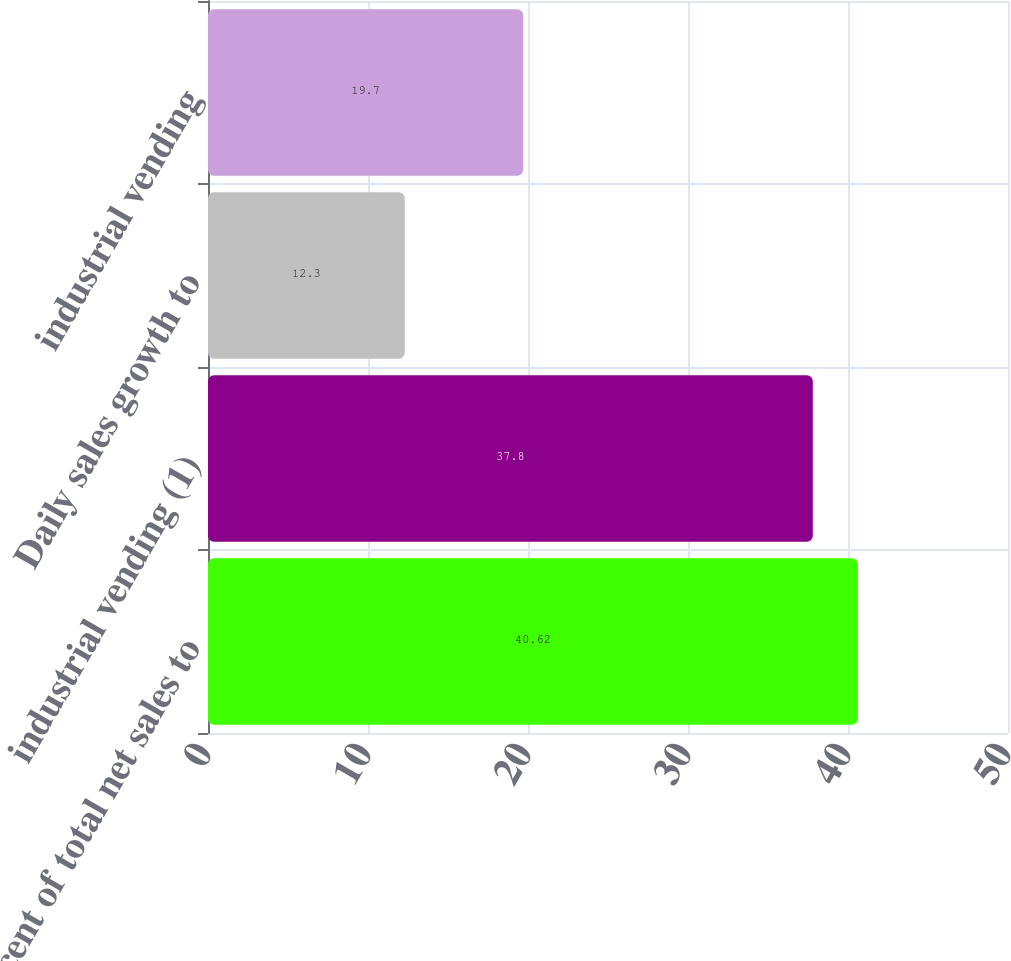Convert chart. <chart><loc_0><loc_0><loc_500><loc_500><bar_chart><fcel>Percent of total net sales to<fcel>industrial vending (1)<fcel>Daily sales growth to<fcel>industrial vending<nl><fcel>40.62<fcel>37.8<fcel>12.3<fcel>19.7<nl></chart> 